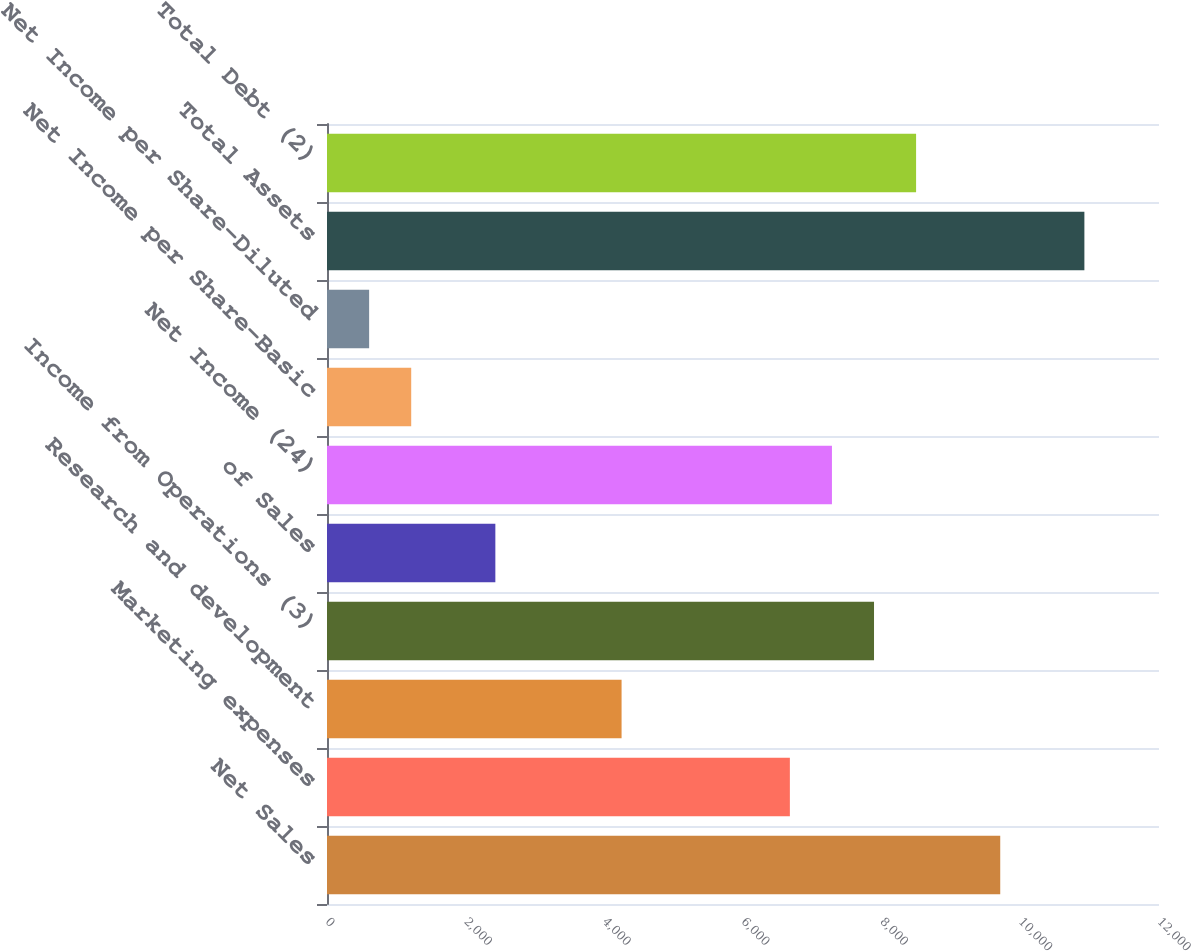Convert chart to OTSL. <chart><loc_0><loc_0><loc_500><loc_500><bar_chart><fcel>Net Sales<fcel>Marketing expenses<fcel>Research and development<fcel>Income from Operations (3)<fcel>of Sales<fcel>Net Income (24)<fcel>Net Income per Share-Basic<fcel>Net Income per Share-Diluted<fcel>Total Assets<fcel>Total Debt (2)<nl><fcel>9710.15<fcel>6676<fcel>4248.68<fcel>7889.66<fcel>2428.19<fcel>7282.83<fcel>1214.53<fcel>607.7<fcel>10923.8<fcel>8496.49<nl></chart> 